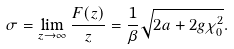<formula> <loc_0><loc_0><loc_500><loc_500>\sigma = \lim _ { z \rightarrow \infty } \frac { F ( z ) } { z } = \frac { 1 } { \beta } \sqrt { 2 a + 2 g \chi _ { 0 } ^ { 2 } } .</formula> 